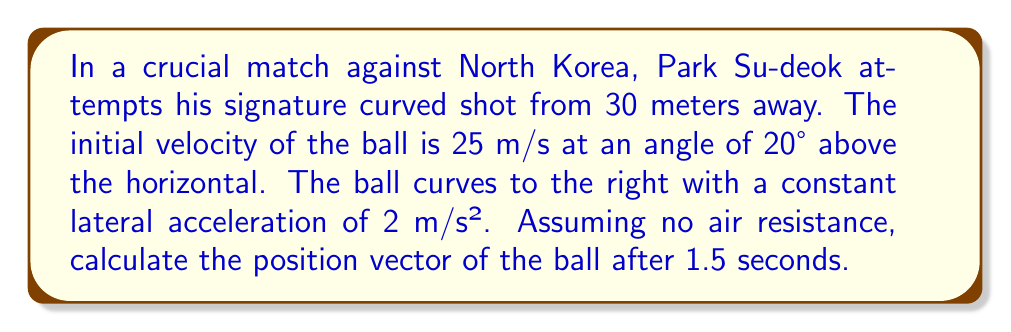Teach me how to tackle this problem. Let's approach this step-by-step using vector mathematics:

1) First, let's define our coordinate system:
   x-axis: direction of the kick
   y-axis: vertical direction
   z-axis: lateral direction (right is positive)

2) Initial velocity vector:
   $$\vec{v_0} = (25\cos20°, 25\sin20°, 0) = (23.48, 8.55, 0)$$ m/s

3) Acceleration vector:
   $$\vec{a} = (0, -9.8, 2)$$ m/s²
   (gravity in y-direction, lateral acceleration in z-direction)

4) Position vector as a function of time:
   $$\vec{r}(t) = \vec{r_0} + \vec{v_0}t + \frac{1}{2}\vec{a}t^2$$

5) Initial position $\vec{r_0} = (0, 0, 0)$

6) Substituting values for t = 1.5s:
   $$\vec{r}(1.5) = (0, 0, 0) + (23.48, 8.55, 0)(1.5) + \frac{1}{2}(0, -9.8, 2)(1.5)^2$$

7) Calculating each component:
   x: $23.48 * 1.5 = 35.22$ m
   y: $8.55 * 1.5 + \frac{1}{2} * (-9.8) * (1.5)^2 = 5.51$ m
   z: $\frac{1}{2} * 2 * (1.5)^2 = 2.25$ m

8) Therefore, the position vector after 1.5 seconds is:
   $$\vec{r}(1.5) = (35.22, 5.51, 2.25)$$ m
Answer: $(35.22, 5.51, 2.25)$ m 